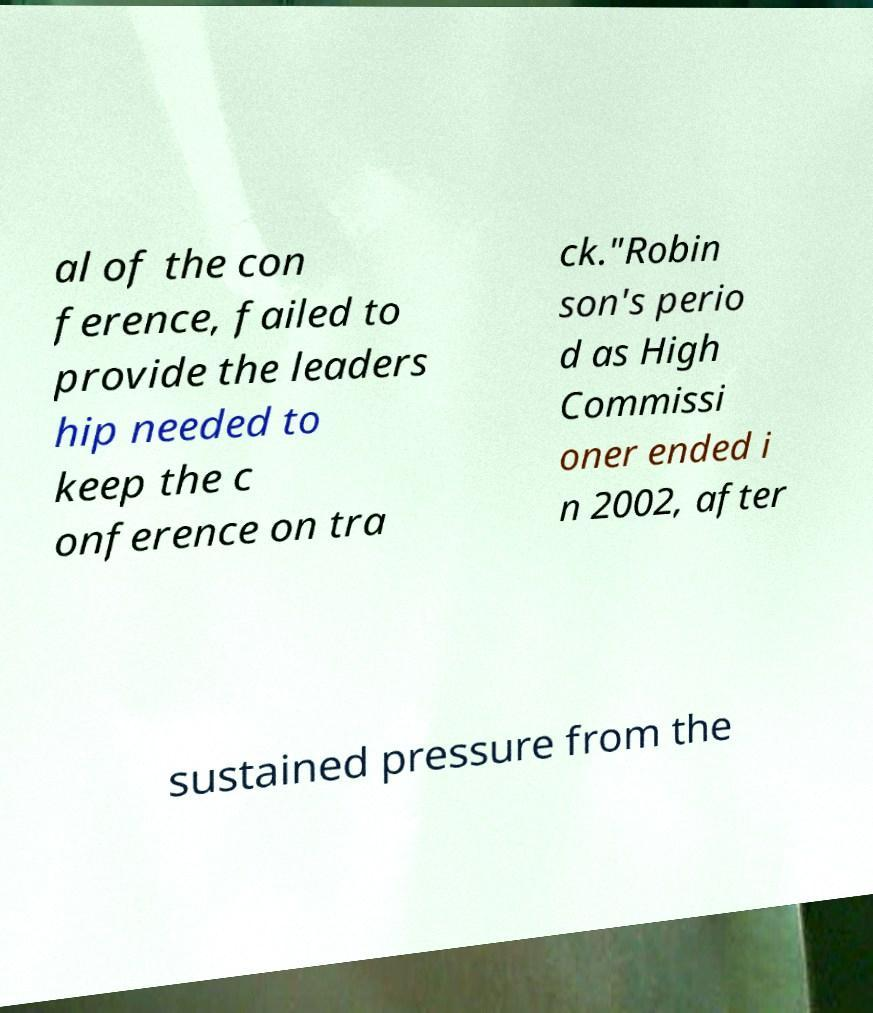What messages or text are displayed in this image? I need them in a readable, typed format. al of the con ference, failed to provide the leaders hip needed to keep the c onference on tra ck."Robin son's perio d as High Commissi oner ended i n 2002, after sustained pressure from the 